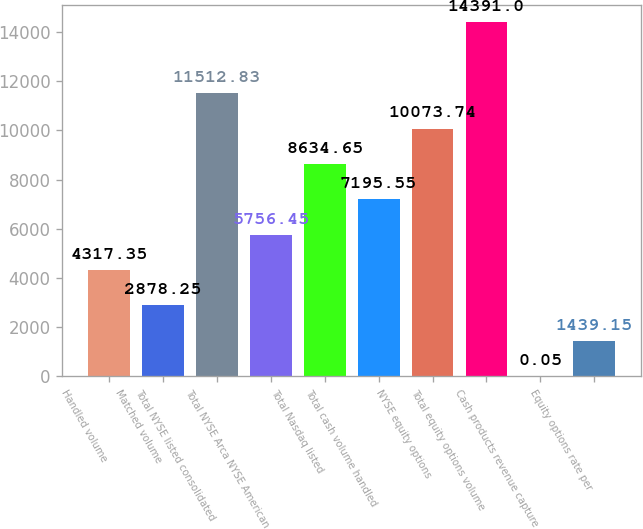Convert chart to OTSL. <chart><loc_0><loc_0><loc_500><loc_500><bar_chart><fcel>Handled volume<fcel>Matched volume<fcel>Total NYSE listed consolidated<fcel>Total NYSE Arca NYSE American<fcel>Total Nasdaq listed<fcel>Total cash volume handled<fcel>NYSE equity options<fcel>Total equity options volume<fcel>Cash products revenue capture<fcel>Equity options rate per<nl><fcel>4317.35<fcel>2878.25<fcel>11512.8<fcel>5756.45<fcel>8634.65<fcel>7195.55<fcel>10073.7<fcel>14391<fcel>0.05<fcel>1439.15<nl></chart> 